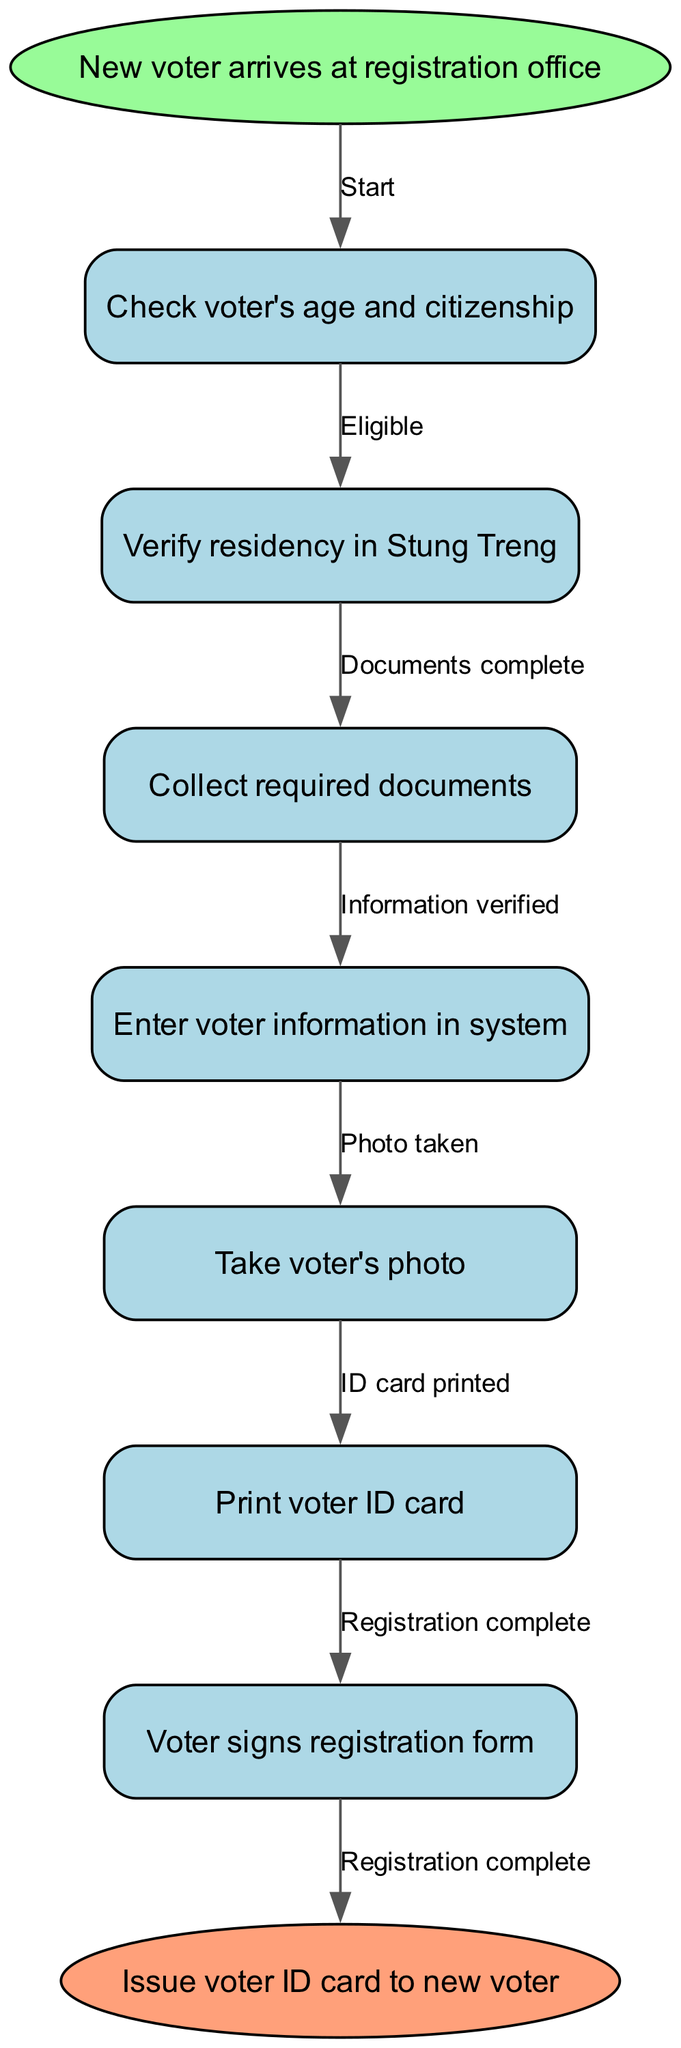What is the starting point of the voter registration process? The starting point is defined as the initial node in the flowchart, which states "New voter arrives at registration office."
Answer: New voter arrives at registration office How many nodes are there in the diagram? The number of nodes can be calculated by counting the various steps and the start and end nodes. There are 7 nodes in total: 1 start node, 5 process nodes, and 1 end node.
Answer: 7 What is the last step in the voter registration process? The last step is indicated by the final process node before reaching the end node, which states "Print voter ID card."
Answer: Print voter ID card What edge represents the connection between verifying residency and sending to the next node? The edge that connects verifying residency to the next step is labeled "Documents complete," indicating that the process moves forward once the residency is verified.
Answer: Documents complete After taking the voter's photo, what is the next step? The flow of the diagram shows that after the step "Take voter's photo," the next step is "Print voter ID card." This concludes that taking a photo is followed by printing the ID.
Answer: Print voter ID card How many edges are there leading to the end node? To find the number of edges leading to the end node, examine the paths outlined in the diagram. There is 1 edge labeled "Registration complete" that directly connects to the end node.
Answer: 1 What must occur before a voter can sign the registration form? According to the flowchart, the voter must first "Enter voter information in system" before they can sign the registration form. This indicates a sequential requirement in the process.
Answer: Enter voter information in system What is required before entering voter information into the system? The flowchart outlines the steps sequentially, and to enter voter information into the system, the prerequisite is to "Collect required documents." This shows the dependency of the steps.
Answer: Collect required documents What step follows after verifying the voter's age and citizenship? The next step, as indicated in the flowchart, immediately after verifying the voter's age and citizenship is "Verify residency in Stung Treng." This shows the progression of the registration process.
Answer: Verify residency in Stung Treng 